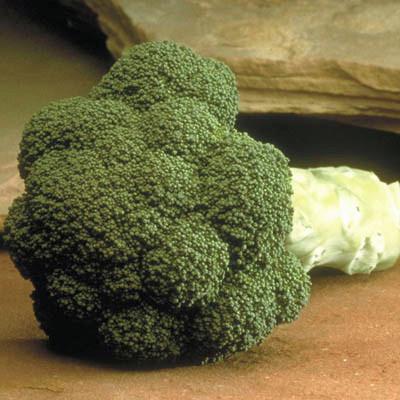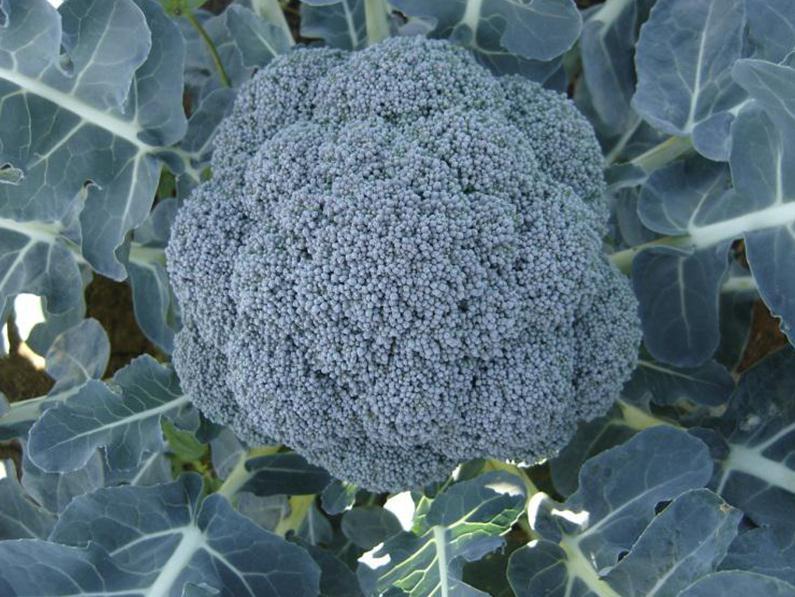The first image is the image on the left, the second image is the image on the right. For the images displayed, is the sentence "The left and right image contains the same number broccoli heads growing straight up." factually correct? Answer yes or no. No. 